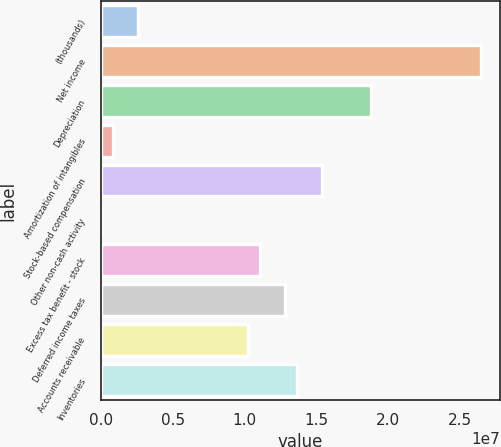<chart> <loc_0><loc_0><loc_500><loc_500><bar_chart><fcel>(thousands)<fcel>Net income<fcel>Depreciation<fcel>Amortization of intangibles<fcel>Stock-based compensation<fcel>Other non-cash activity<fcel>Excess tax benefit - stock<fcel>Deferred income taxes<fcel>Accounts receivable<fcel>Inventories<nl><fcel>2.56223e+06<fcel>2.64746e+07<fcel>1.87885e+07<fcel>854200<fcel>1.53725e+07<fcel>185<fcel>1.11024e+07<fcel>1.28104e+07<fcel>1.02484e+07<fcel>1.36644e+07<nl></chart> 